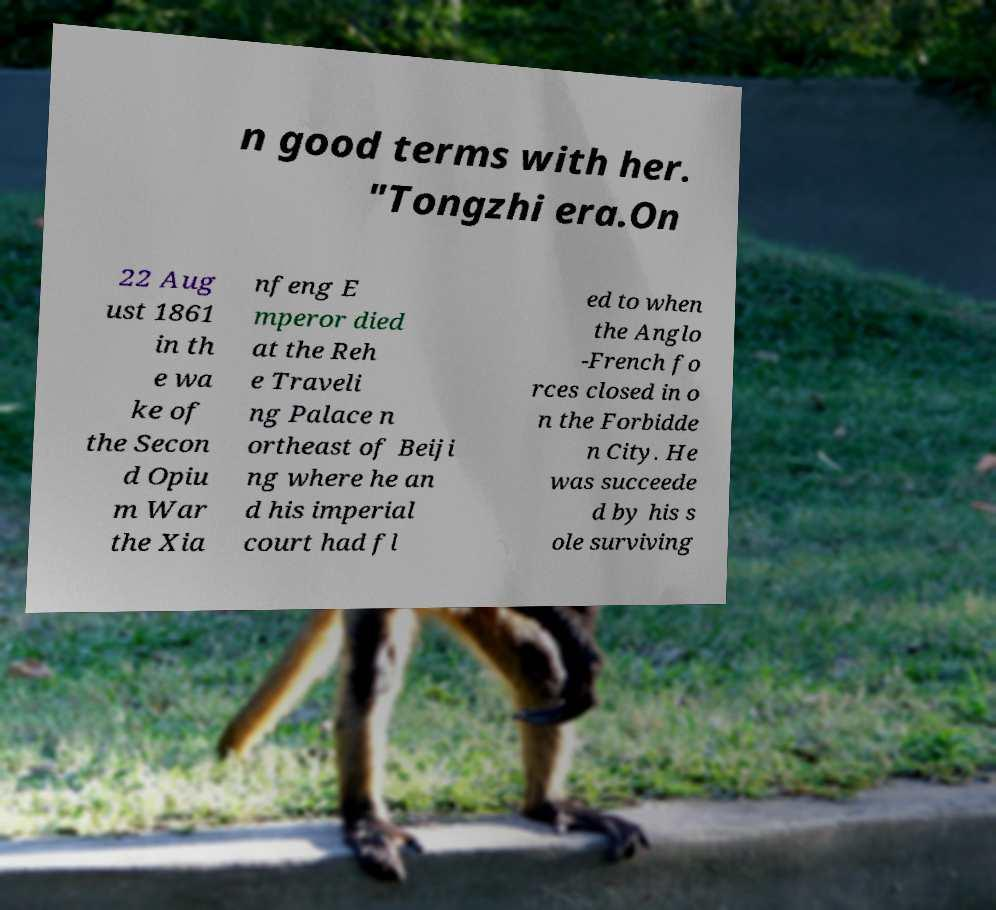Could you extract and type out the text from this image? n good terms with her. "Tongzhi era.On 22 Aug ust 1861 in th e wa ke of the Secon d Opiu m War the Xia nfeng E mperor died at the Reh e Traveli ng Palace n ortheast of Beiji ng where he an d his imperial court had fl ed to when the Anglo -French fo rces closed in o n the Forbidde n City. He was succeede d by his s ole surviving 